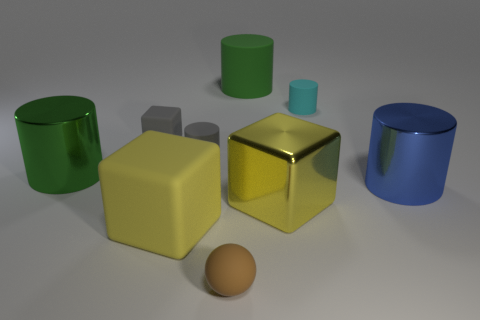Is the big matte cube the same color as the metallic block?
Your response must be concise. Yes. There is a thing that is the same color as the shiny block; what material is it?
Offer a terse response. Rubber. How many matte objects are either large blocks or tiny things?
Offer a terse response. 5. What number of other objects are there of the same shape as the tiny brown rubber object?
Offer a very short reply. 0. Are there more small gray matte cylinders than purple matte things?
Give a very brief answer. Yes. What size is the green object behind the green object in front of the small object that is on the right side of the big yellow metal block?
Keep it short and to the point. Large. There is a green thing left of the tiny rubber block; how big is it?
Offer a terse response. Large. How many things are green shiny things or rubber objects in front of the yellow shiny cube?
Offer a very short reply. 3. How many other things are the same size as the yellow matte block?
Keep it short and to the point. 4. There is a cyan thing that is the same shape as the large green rubber thing; what is it made of?
Make the answer very short. Rubber. 